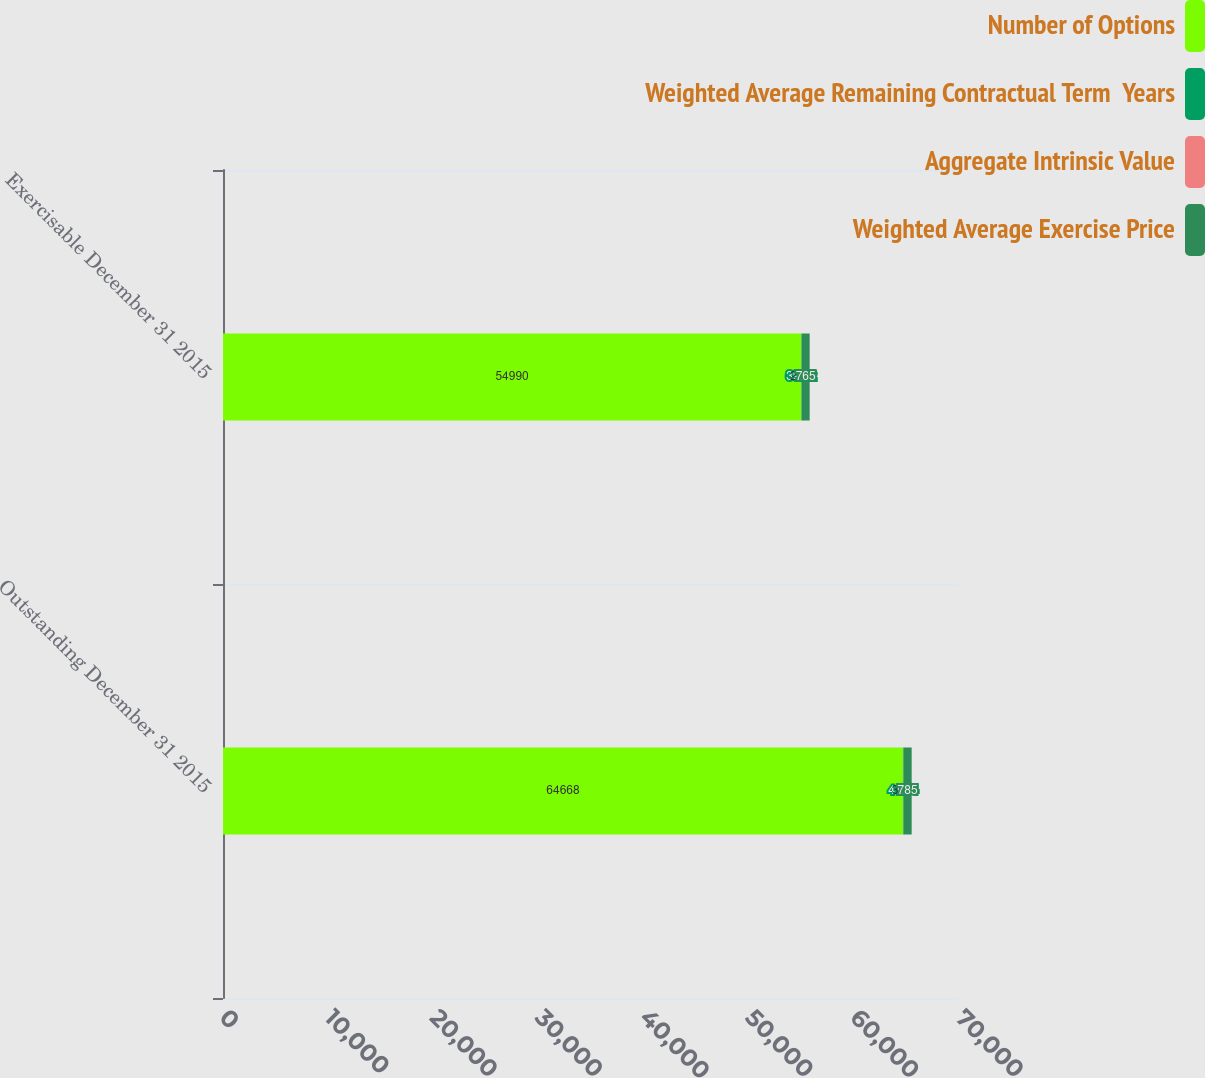Convert chart. <chart><loc_0><loc_0><loc_500><loc_500><stacked_bar_chart><ecel><fcel>Outstanding December 31 2015<fcel>Exercisable December 31 2015<nl><fcel>Number of Options<fcel>64668<fcel>54990<nl><fcel>Weighted Average Remaining Contractual Term  Years<fcel>41.64<fcel>39.12<nl><fcel>Aggregate Intrinsic Value<fcel>3.71<fcel>2.87<nl><fcel>Weighted Average Exercise Price<fcel>785<fcel>765<nl></chart> 